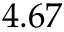Convert formula to latex. <formula><loc_0><loc_0><loc_500><loc_500>4 . 6 7</formula> 